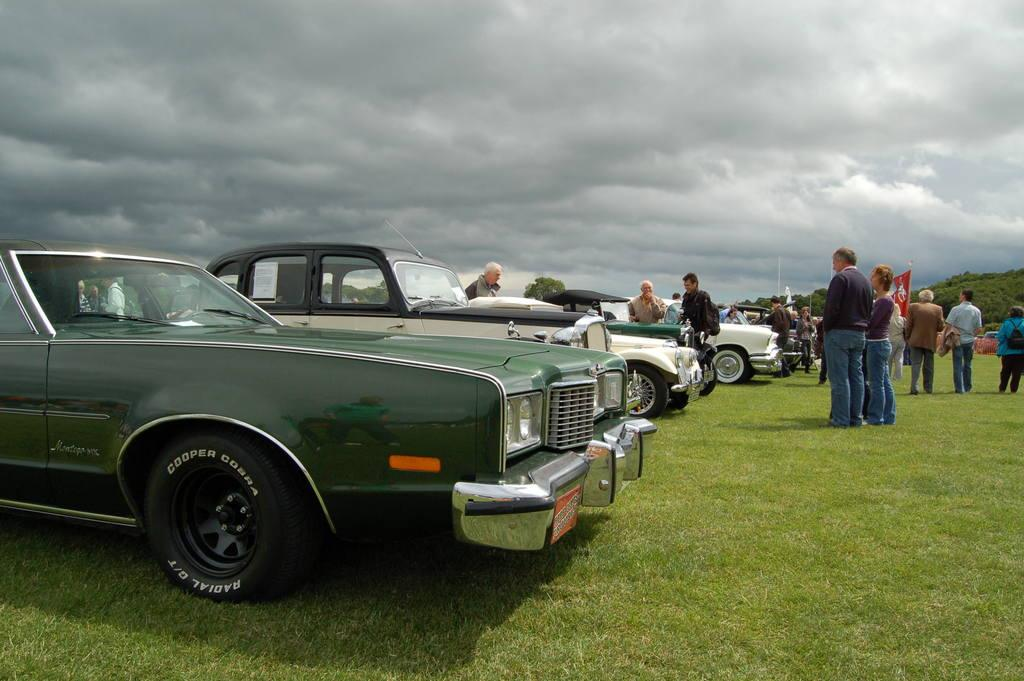What type of surface is visible in the front of the image? There is grass on the ground in the front of the image. What can be seen in the center of the image? There are vehicles in the center of the image. What is visible in the background of the image? There are persons, trees, a flag, and a cloudy sky in the background of the image. What type of game is being played by the persons in the background of the image? There is no game being played by the persons in the image; the persons are simply visible in the background. Can you tell me what kind of eggnog is being served at the event in the image? There is no mention of eggnog or any event in the image; it features vehicles, grass, trees, and a flag in the background. 